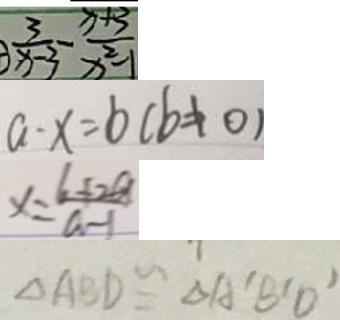<formula> <loc_0><loc_0><loc_500><loc_500>\frac { 3 } { x - 3 } - \frac { x + 3 } { x ^ { 2 } - 1 } 
 a - x = b ( b \neq 0 ) 
 x = \frac { 6 + 2 a } { a - 1 } 
 \Delta A B D \cong \Delta A ^ { \prime } B ^ { \prime } D ^ { \prime }</formula> 